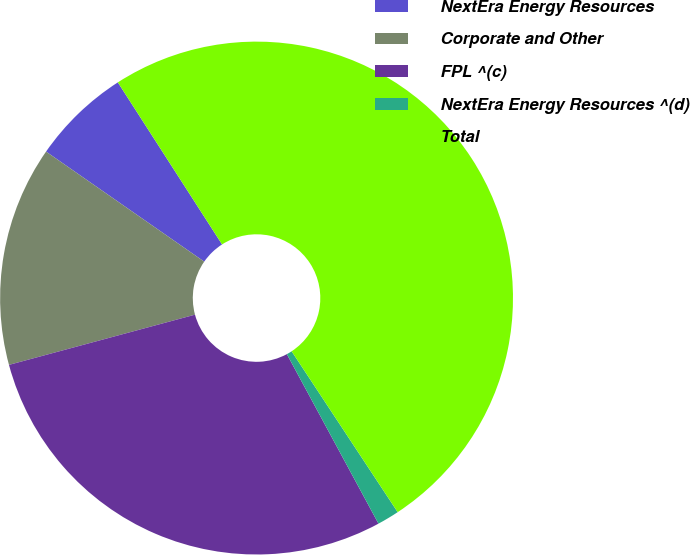Convert chart. <chart><loc_0><loc_0><loc_500><loc_500><pie_chart><fcel>NextEra Energy Resources<fcel>Corporate and Other<fcel>FPL ^(c)<fcel>NextEra Energy Resources ^(d)<fcel>Total<nl><fcel>6.23%<fcel>13.87%<fcel>28.69%<fcel>1.39%<fcel>49.82%<nl></chart> 